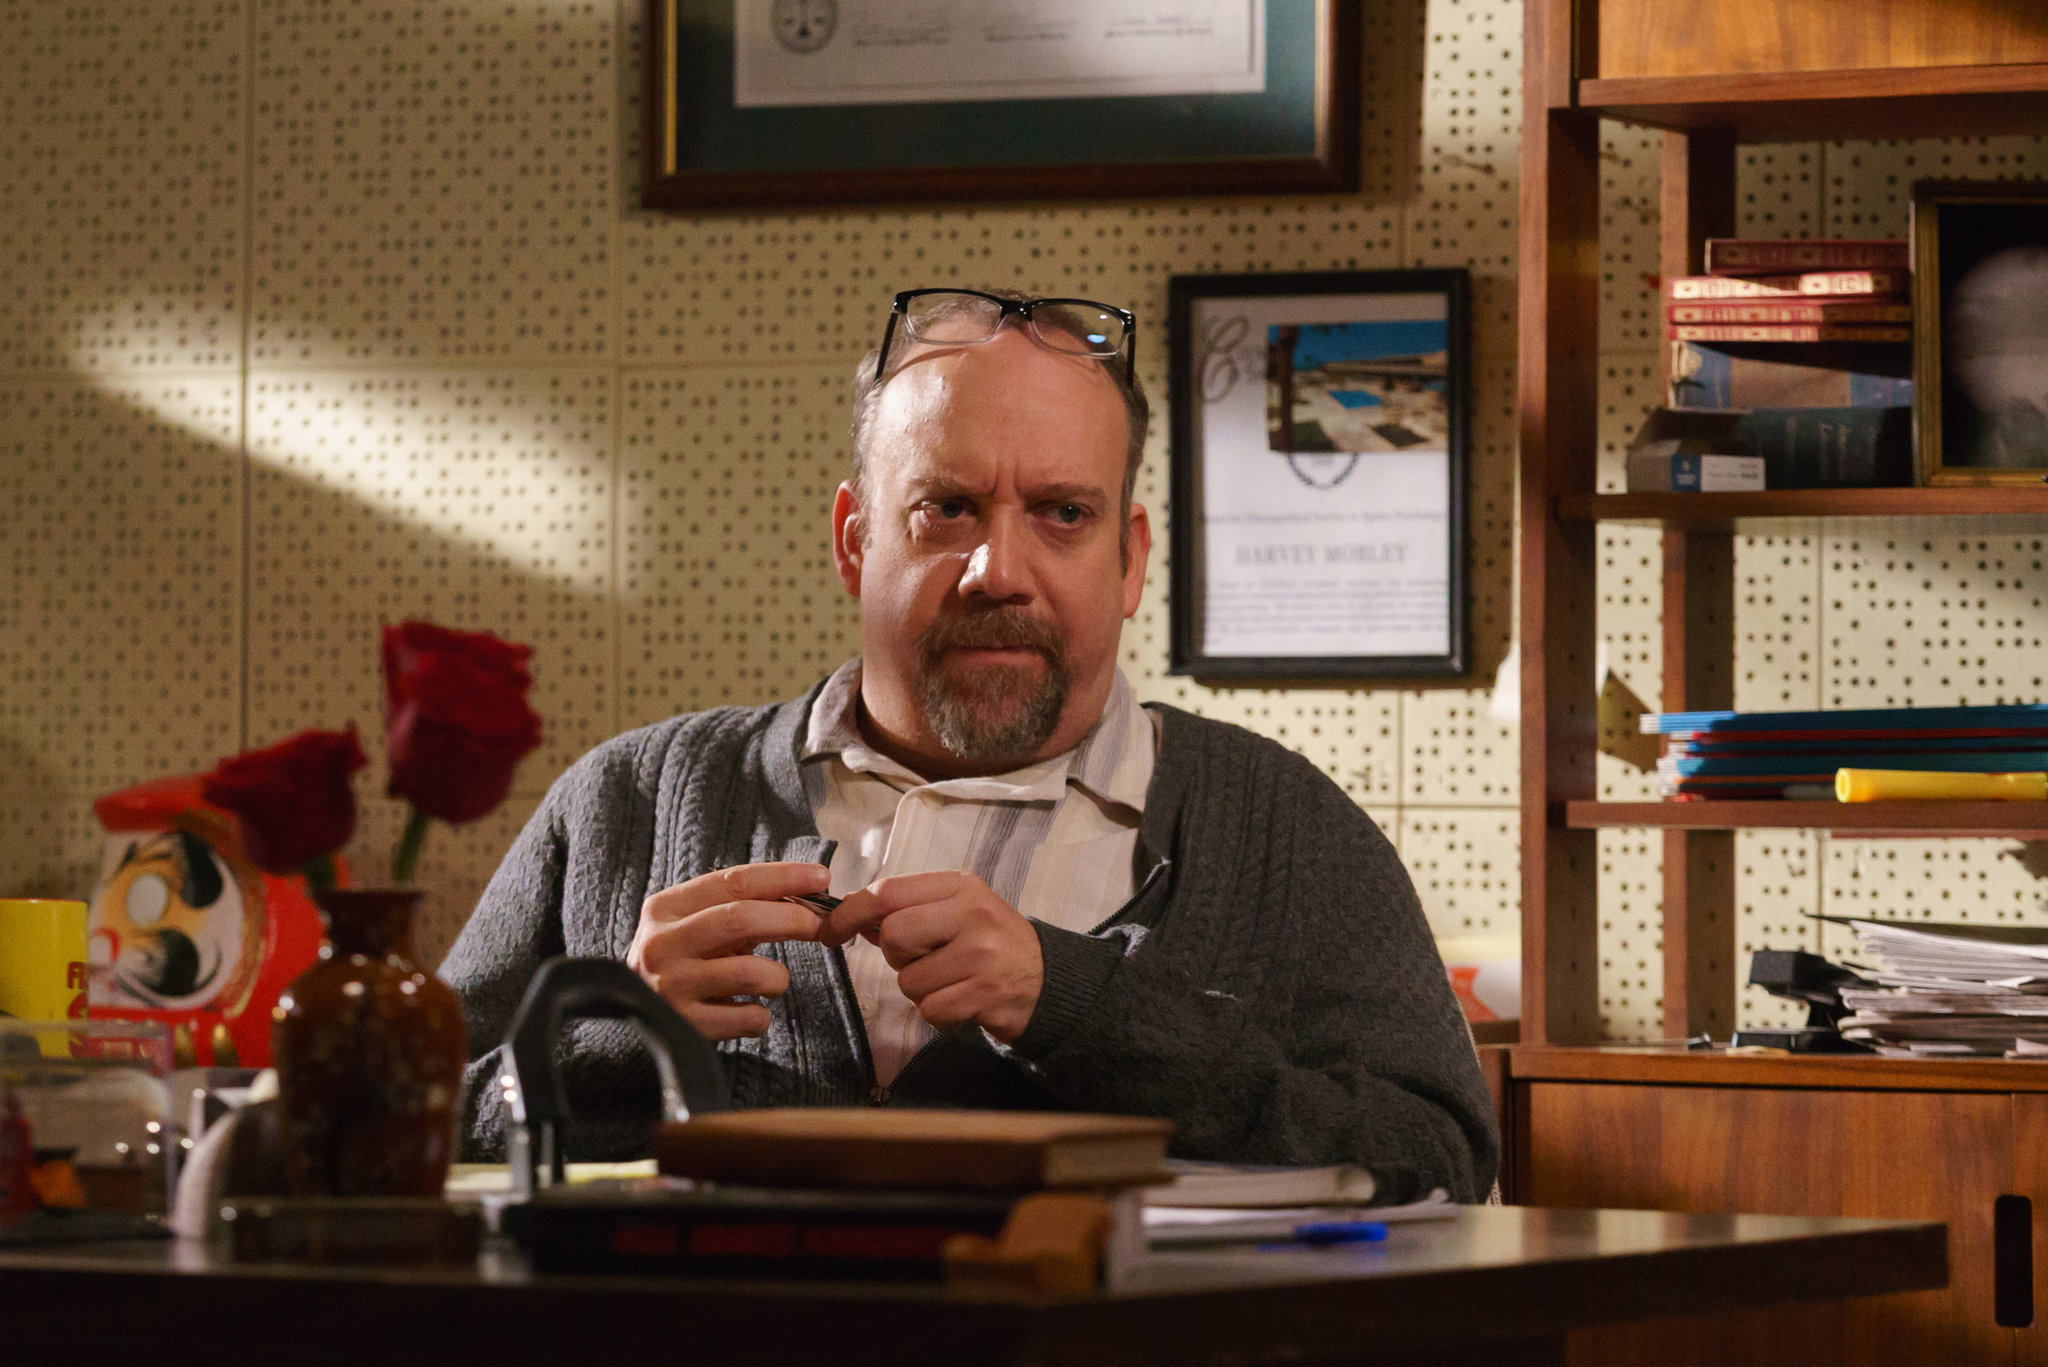If this were a scene in a movie, what kind of narrative or story could this image belong to? This image could very well be a scene from a dramatic movie or a biographical film. It might belong to a narrative focusing on a brilliant yet troubled intellectual, such as a writer, professor, or scientist, who is facing a pivotal moment in their career. The contemplative expression and the cluttered workspace could indicate a crucial juncture where the protagonist is grappling with a significant breakthrough or a profound personal revelation. This scene might illustrate a moment of clarity or decision, pivotal to the storyline, where the character is shown lost in deep thought, perhaps just before a transformative event unfolds. 